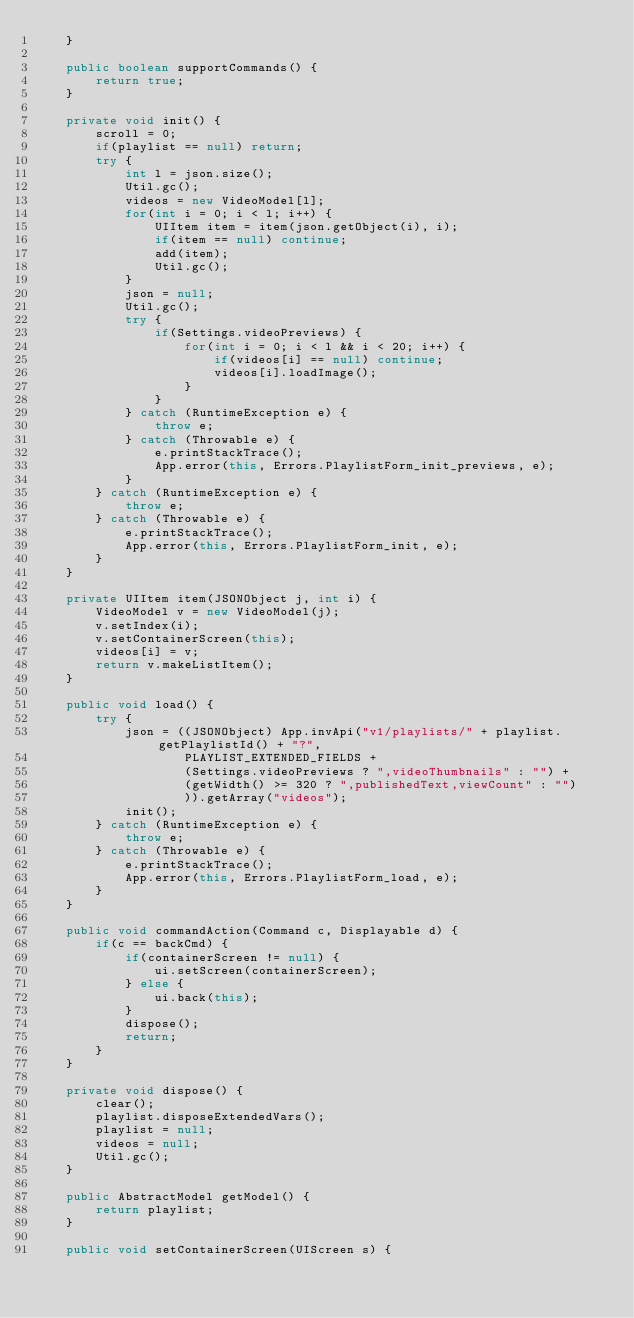Convert code to text. <code><loc_0><loc_0><loc_500><loc_500><_Java_>	}
	
	public boolean supportCommands() {
		return true;
	}
	
	private void init() {
		scroll = 0;
		if(playlist == null) return;
		try {
			int l = json.size();
			Util.gc();
			videos = new VideoModel[l];
			for(int i = 0; i < l; i++) {
				UIItem item = item(json.getObject(i), i);
				if(item == null) continue;
				add(item);
				Util.gc();
			}
			json = null;
			Util.gc();
			try {
				if(Settings.videoPreviews) {
					for(int i = 0; i < l && i < 20; i++) {
						if(videos[i] == null) continue;
						videos[i].loadImage();
					}
				}
			} catch (RuntimeException e) {
				throw e;
			} catch (Throwable e) {
				e.printStackTrace();
				App.error(this, Errors.PlaylistForm_init_previews, e);
			}
		} catch (RuntimeException e) {
			throw e;
		} catch (Throwable e) {
			e.printStackTrace();
			App.error(this, Errors.PlaylistForm_init, e);
		}
	}

	private UIItem item(JSONObject j, int i) {
		VideoModel v = new VideoModel(j);
		v.setIndex(i);
		v.setContainerScreen(this);
		videos[i] = v;
		return v.makeListItem();
	}

	public void load() {
		try {
			json = ((JSONObject) App.invApi("v1/playlists/" + playlist.getPlaylistId() + "?",
					PLAYLIST_EXTENDED_FIELDS +
					(Settings.videoPreviews ? ",videoThumbnails" : "") +
					(getWidth() >= 320 ? ",publishedText,viewCount" : "")
					)).getArray("videos");
			init();
		} catch (RuntimeException e) {
			throw e;
		} catch (Throwable e) {
			e.printStackTrace();
			App.error(this, Errors.PlaylistForm_load, e);
		}
	}

	public void commandAction(Command c, Displayable d) {
		if(c == backCmd) {
			if(containerScreen != null) {
				ui.setScreen(containerScreen);
			} else {
				ui.back(this);
			}
			dispose();
			return;
		}
	}

	private void dispose() {
		clear();
		playlist.disposeExtendedVars();
		playlist = null;
		videos = null;
		Util.gc();
	}

	public AbstractModel getModel() {
		return playlist;
	}

	public void setContainerScreen(UIScreen s) {</code> 